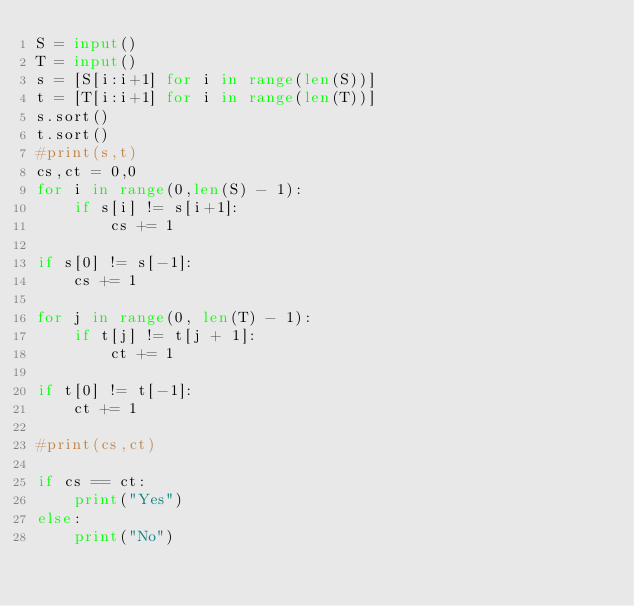<code> <loc_0><loc_0><loc_500><loc_500><_Python_>S = input()
T = input()
s = [S[i:i+1] for i in range(len(S))]
t = [T[i:i+1] for i in range(len(T))]
s.sort()
t.sort()
#print(s,t)
cs,ct = 0,0
for i in range(0,len(S) - 1):
    if s[i] != s[i+1]:
        cs += 1

if s[0] != s[-1]:
    cs += 1

for j in range(0, len(T) - 1):
    if t[j] != t[j + 1]:
        ct += 1

if t[0] != t[-1]:
    ct += 1

#print(cs,ct)

if cs == ct:
    print("Yes")
else:
    print("No")</code> 